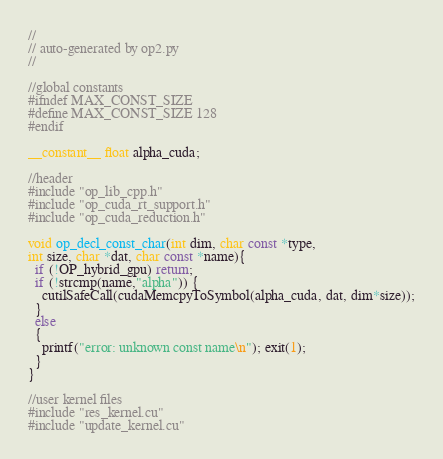<code> <loc_0><loc_0><loc_500><loc_500><_Cuda_>//
// auto-generated by op2.py
//

//global constants
#ifndef MAX_CONST_SIZE
#define MAX_CONST_SIZE 128
#endif

__constant__ float alpha_cuda;

//header
#include "op_lib_cpp.h"
#include "op_cuda_rt_support.h"
#include "op_cuda_reduction.h"

void op_decl_const_char(int dim, char const *type,
int size, char *dat, char const *name){
  if (!OP_hybrid_gpu) return;
  if (!strcmp(name,"alpha")) {
    cutilSafeCall(cudaMemcpyToSymbol(alpha_cuda, dat, dim*size));
  }
  else
  {
    printf("error: unknown const name\n"); exit(1);
  }
}

//user kernel files
#include "res_kernel.cu"
#include "update_kernel.cu"
</code> 